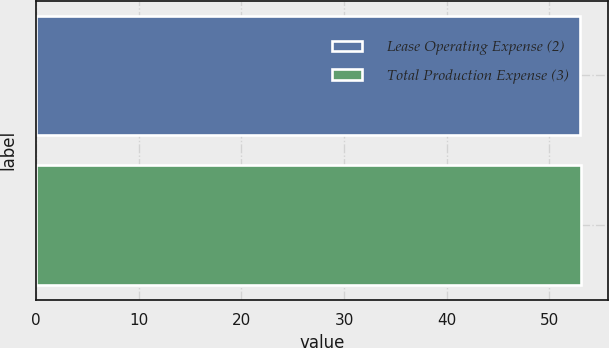Convert chart to OTSL. <chart><loc_0><loc_0><loc_500><loc_500><bar_chart><fcel>Lease Operating Expense (2)<fcel>Total Production Expense (3)<nl><fcel>53<fcel>53.1<nl></chart> 